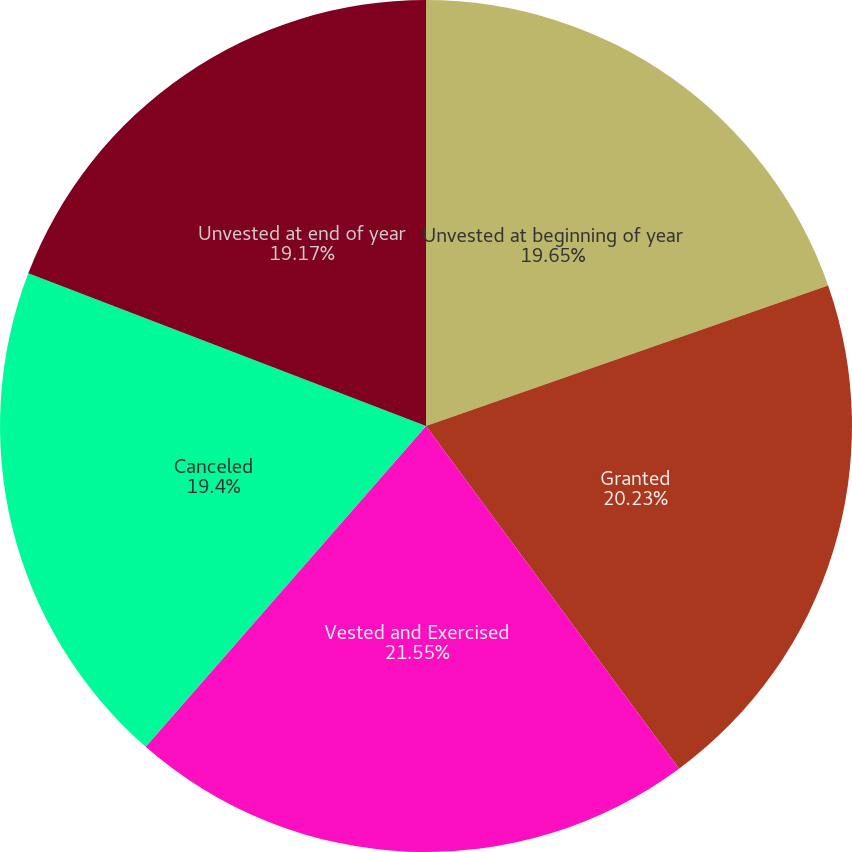Convert chart. <chart><loc_0><loc_0><loc_500><loc_500><pie_chart><fcel>Unvested at beginning of year<fcel>Granted<fcel>Vested and Exercised<fcel>Canceled<fcel>Unvested at end of year<nl><fcel>19.65%<fcel>20.23%<fcel>21.56%<fcel>19.4%<fcel>19.17%<nl></chart> 